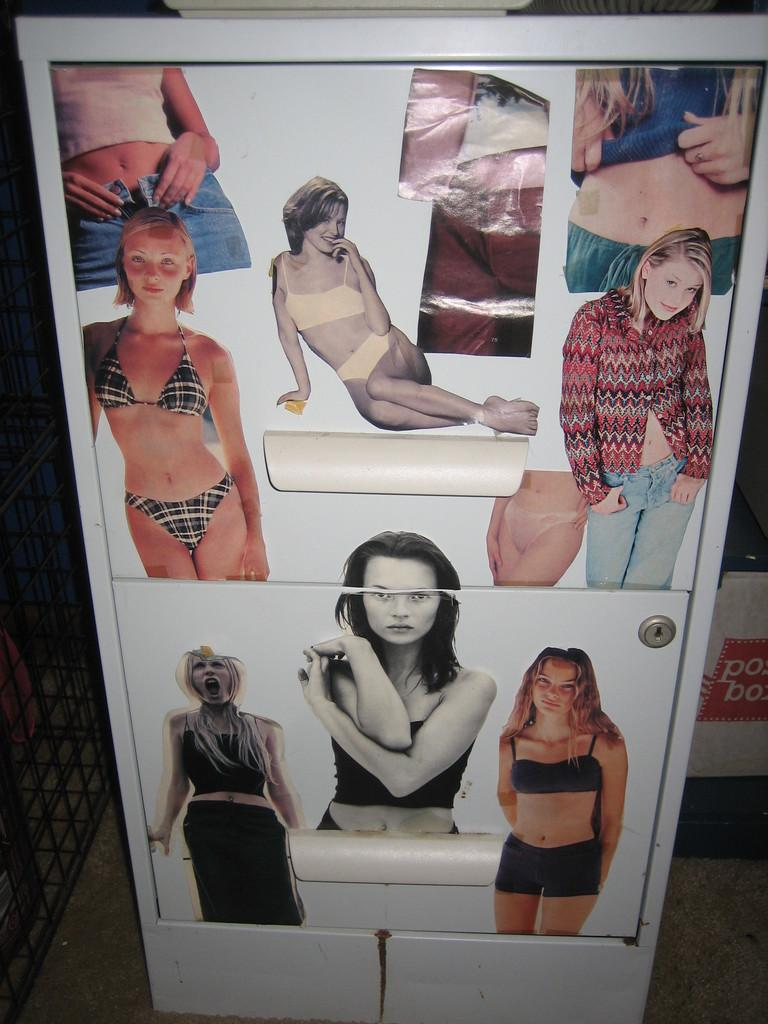What is the main subject of the image? There is an object in the image. What can be seen on the object? The object has pictures of women on it. What type of copper material is used to make the object in the image? There is no mention of copper or any specific material used to make the object in the image. 